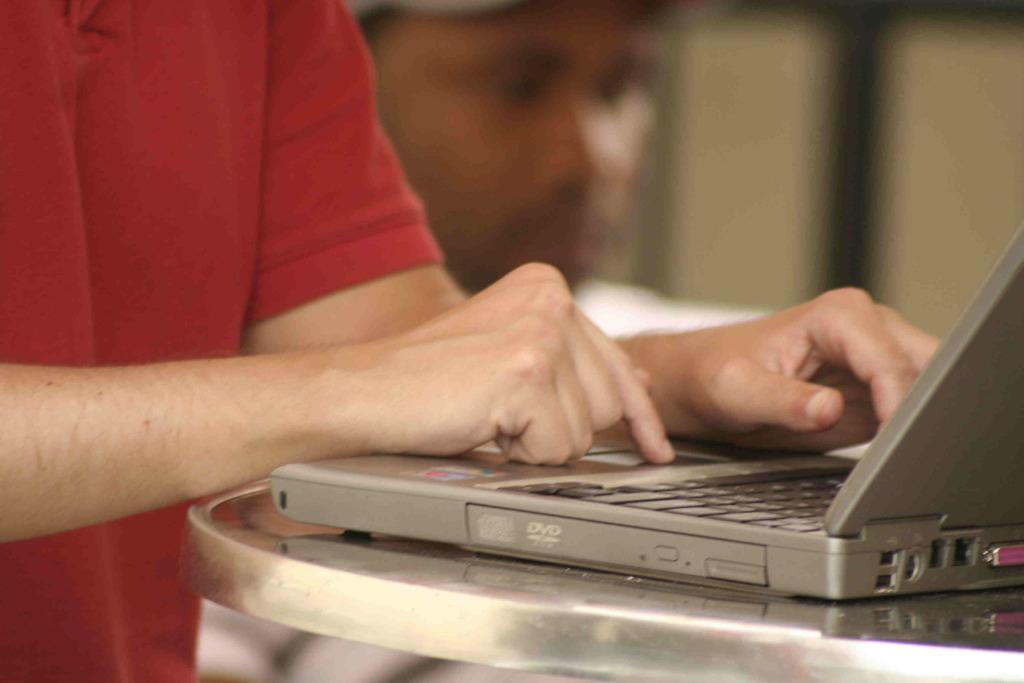<image>
Provide a brief description of the given image. A person is working on a laptop that has a DVD player on the side of it. 